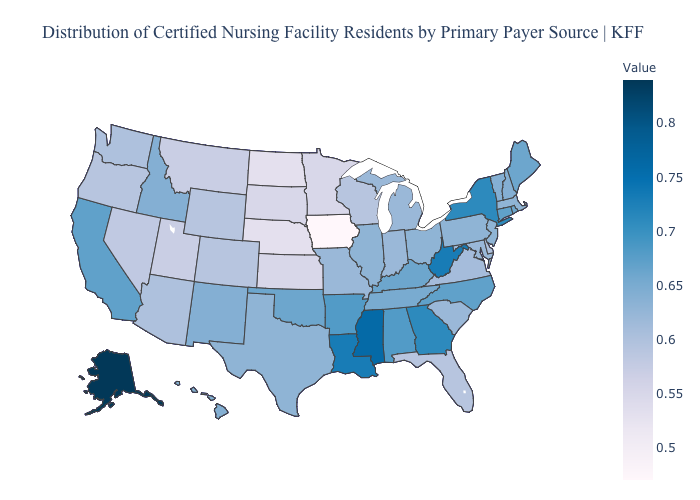Does Louisiana have a lower value than Rhode Island?
Give a very brief answer. No. Does New York have the highest value in the Northeast?
Keep it brief. Yes. Which states have the highest value in the USA?
Concise answer only. Alaska. Which states have the lowest value in the USA?
Short answer required. Iowa. Does the map have missing data?
Answer briefly. No. Among the states that border Michigan , does Indiana have the lowest value?
Concise answer only. No. 